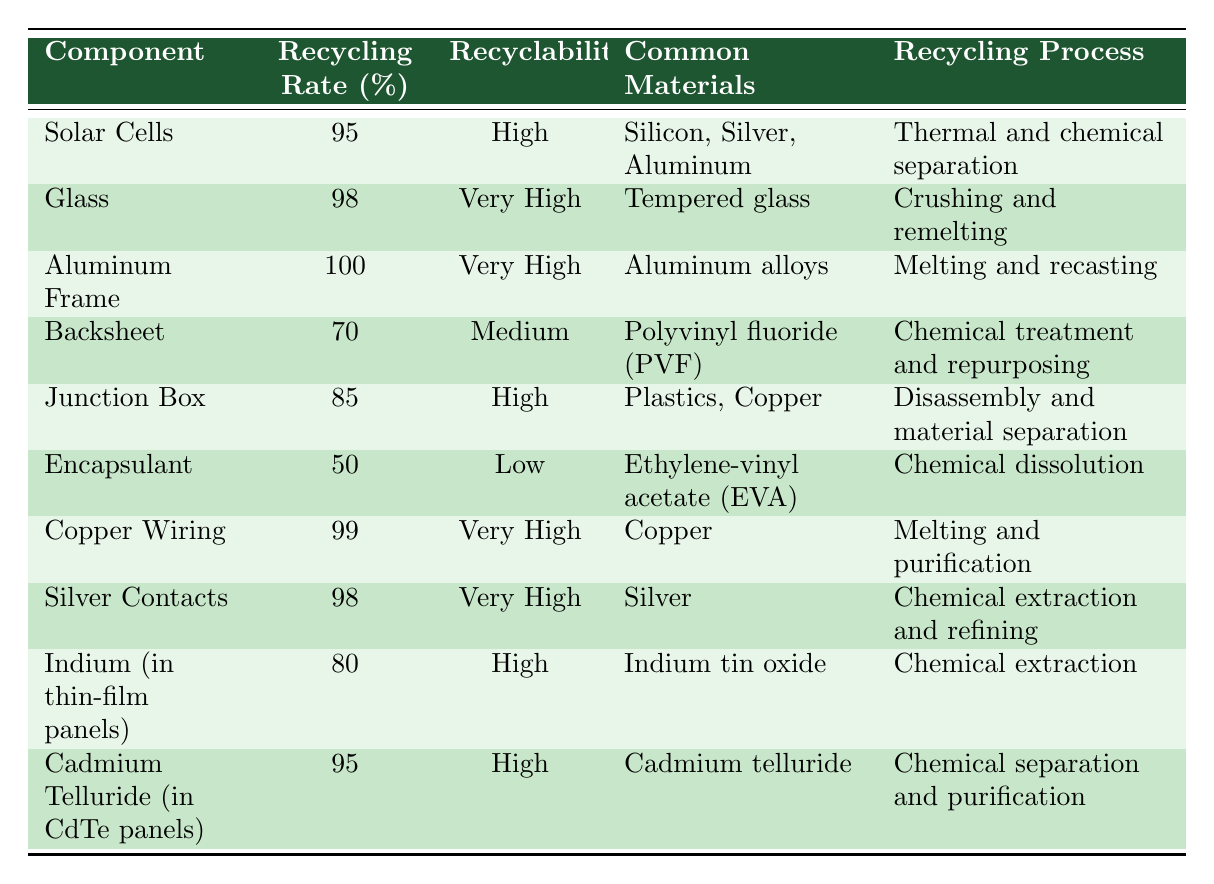What is the recycling rate of solar cells? The table states that the recycling rate of solar cells is listed directly under that component, showing 95%.
Answer: 95% Which component has the highest recycling rate? By comparing the recycling rates listed in the table, the aluminum frame has a recycling rate of 100%, which is the highest among all components.
Answer: Aluminum Frame What common materials are used in the junction box? The table indicates that the junction box is made from plastics and copper, listed in the "Common Materials" column.
Answer: Plastics, Copper Is the encapsulant highly recyclable? The table lists the recyclability of the encapsulant as "Low," indicating that it is not highly recyclable.
Answer: No Calculate the average recycling rate of the components in the table. To find the average, sum the recycling rates: 95 + 98 + 100 + 70 + 85 + 50 + 99 + 98 + 80 + 95 =  1000. There are 10 components, so divide 1000 by 10, which equals 100.
Answer: 100 Which component, if any, has a recycling rate below 75%? By examining the table, the backsheet has a recycling rate of 70%, which is below 75%, making it the only component with that recycling rate.
Answer: Backsheet Are silver contacts regarded as having very high recyclability? Yes, the table lists the recyclability of silver contacts as "Very High," confirming this fact.
Answer: Yes What recycling process is used for glass? The recycling process for glass, as stated in the table, involves crushing and remelting.
Answer: Crushing and remelting Identify which two components have a recycling rate greater than 95%. The aluminum frame (100%) and copper wiring (99%) both have recycling rates above 95%, as seen in the respective rows of the table.
Answer: Aluminum Frame, Copper Wiring If a component has a medium recyclability, what is its recycling rate? Referring to the table, the backsheet has a recycling rate of 70%, which corresponds to medium recyclability.
Answer: 70% 